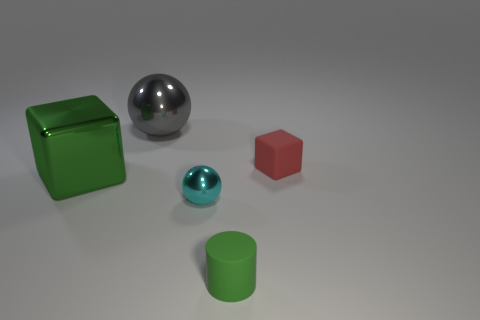Add 2 green balls. How many objects exist? 7 Subtract all green cubes. How many cubes are left? 1 Subtract all cylinders. How many objects are left? 4 Subtract all red cylinders. How many cyan balls are left? 1 Subtract 0 yellow cylinders. How many objects are left? 5 Subtract 1 blocks. How many blocks are left? 1 Subtract all purple cylinders. Subtract all green blocks. How many cylinders are left? 1 Subtract all cylinders. Subtract all big metal cubes. How many objects are left? 3 Add 3 tiny cyan shiny spheres. How many tiny cyan shiny spheres are left? 4 Add 3 small cyan metal objects. How many small cyan metal objects exist? 4 